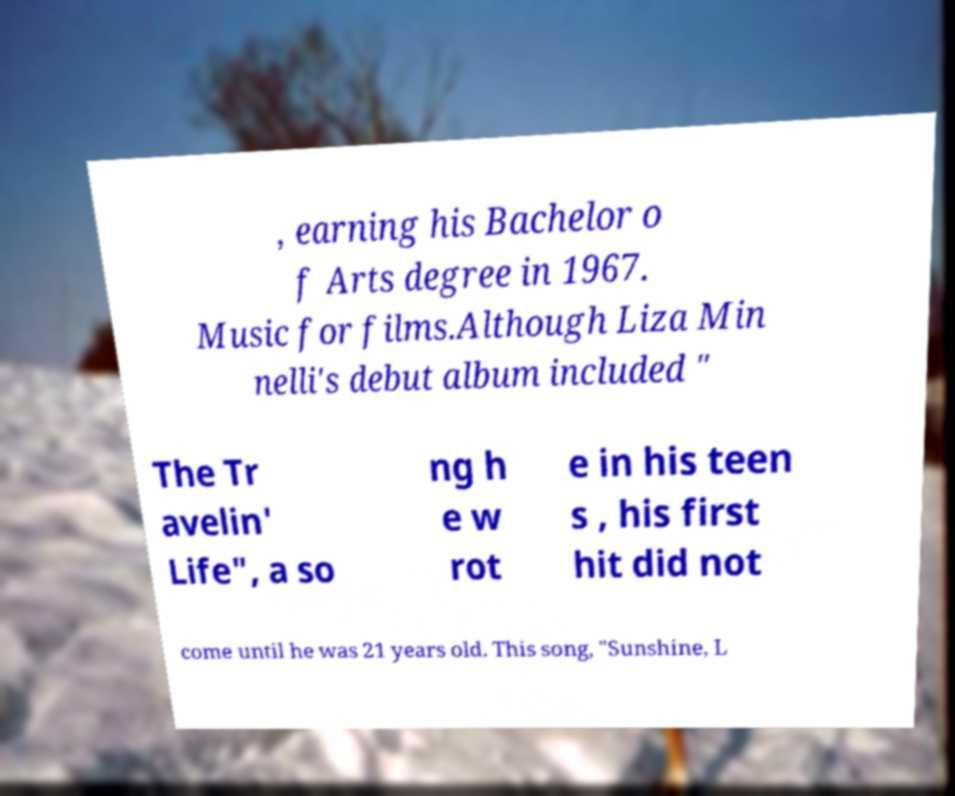Can you accurately transcribe the text from the provided image for me? , earning his Bachelor o f Arts degree in 1967. Music for films.Although Liza Min nelli's debut album included " The Tr avelin' Life", a so ng h e w rot e in his teen s , his first hit did not come until he was 21 years old. This song, "Sunshine, L 